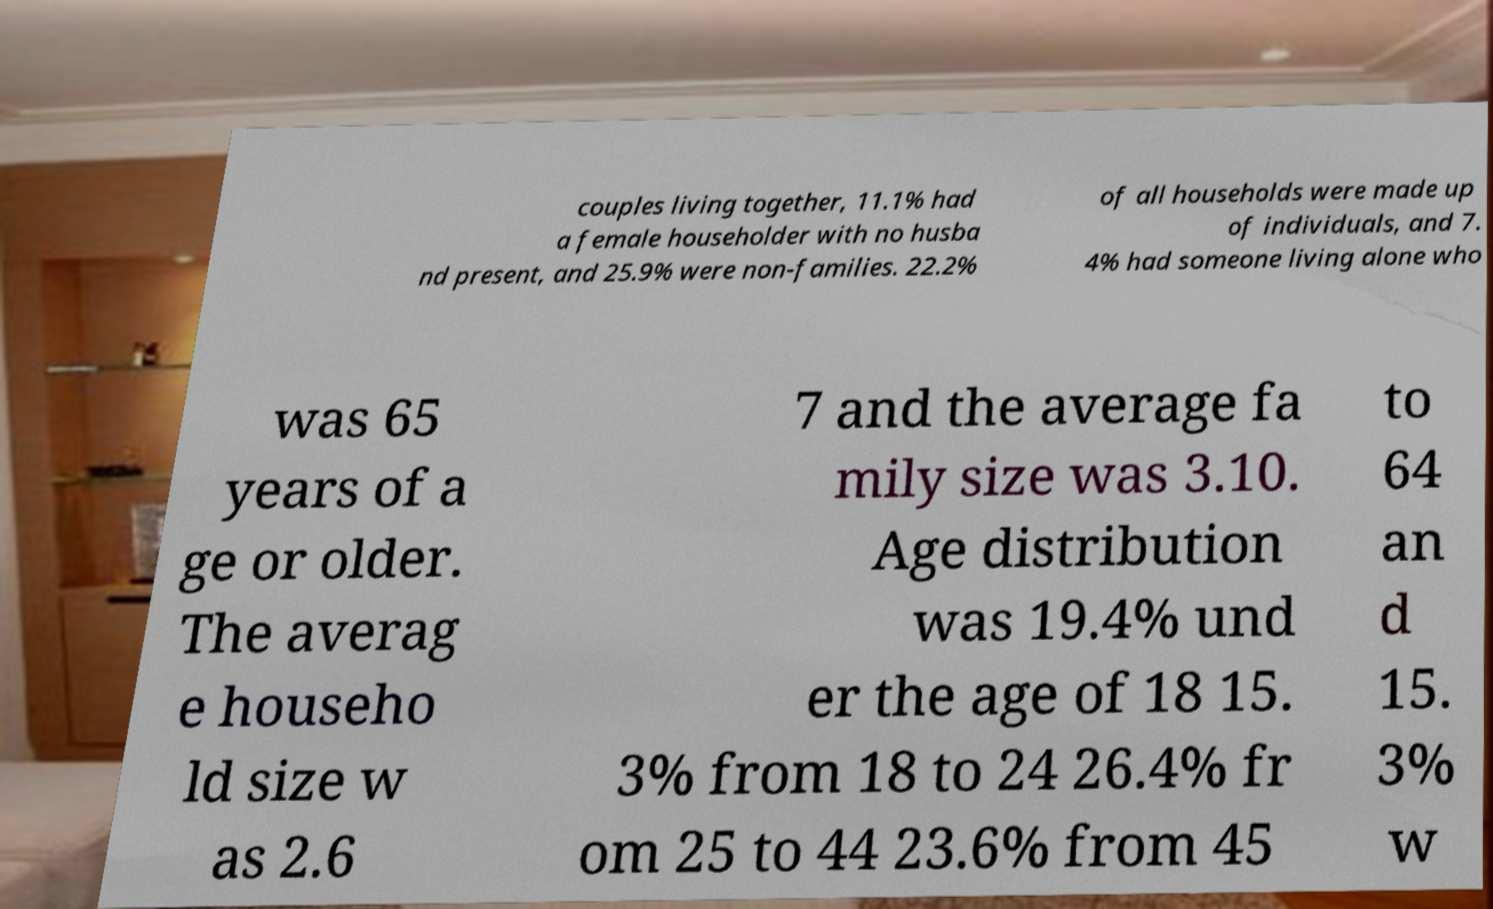Please identify and transcribe the text found in this image. couples living together, 11.1% had a female householder with no husba nd present, and 25.9% were non-families. 22.2% of all households were made up of individuals, and 7. 4% had someone living alone who was 65 years of a ge or older. The averag e househo ld size w as 2.6 7 and the average fa mily size was 3.10. Age distribution was 19.4% und er the age of 18 15. 3% from 18 to 24 26.4% fr om 25 to 44 23.6% from 45 to 64 an d 15. 3% w 